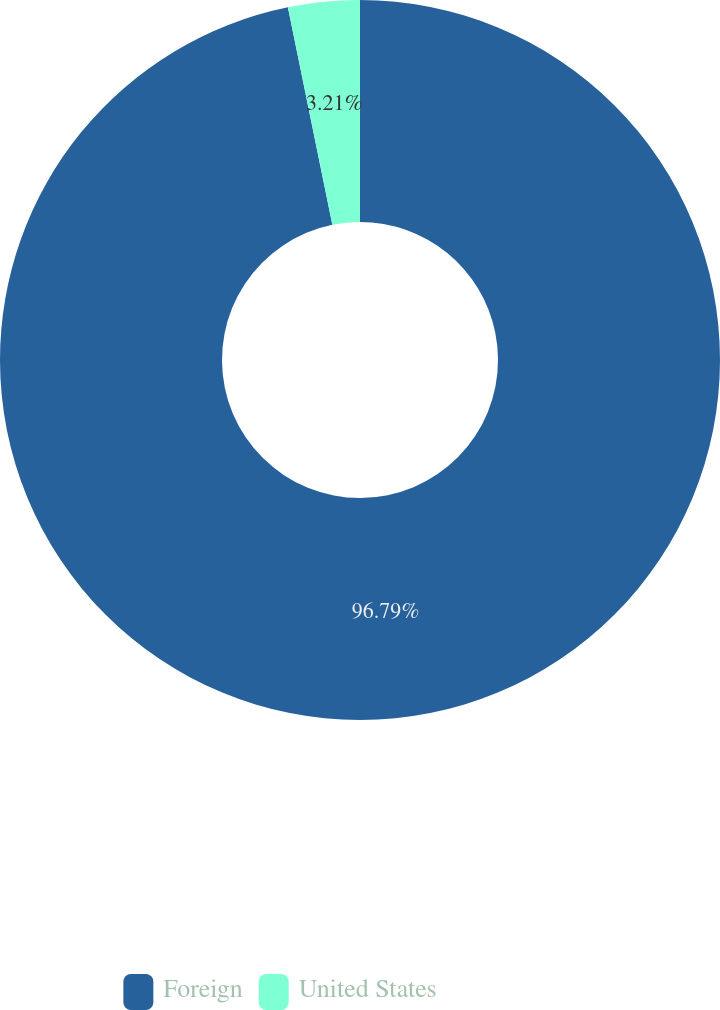<chart> <loc_0><loc_0><loc_500><loc_500><pie_chart><fcel>Foreign<fcel>United States<nl><fcel>96.79%<fcel>3.21%<nl></chart> 